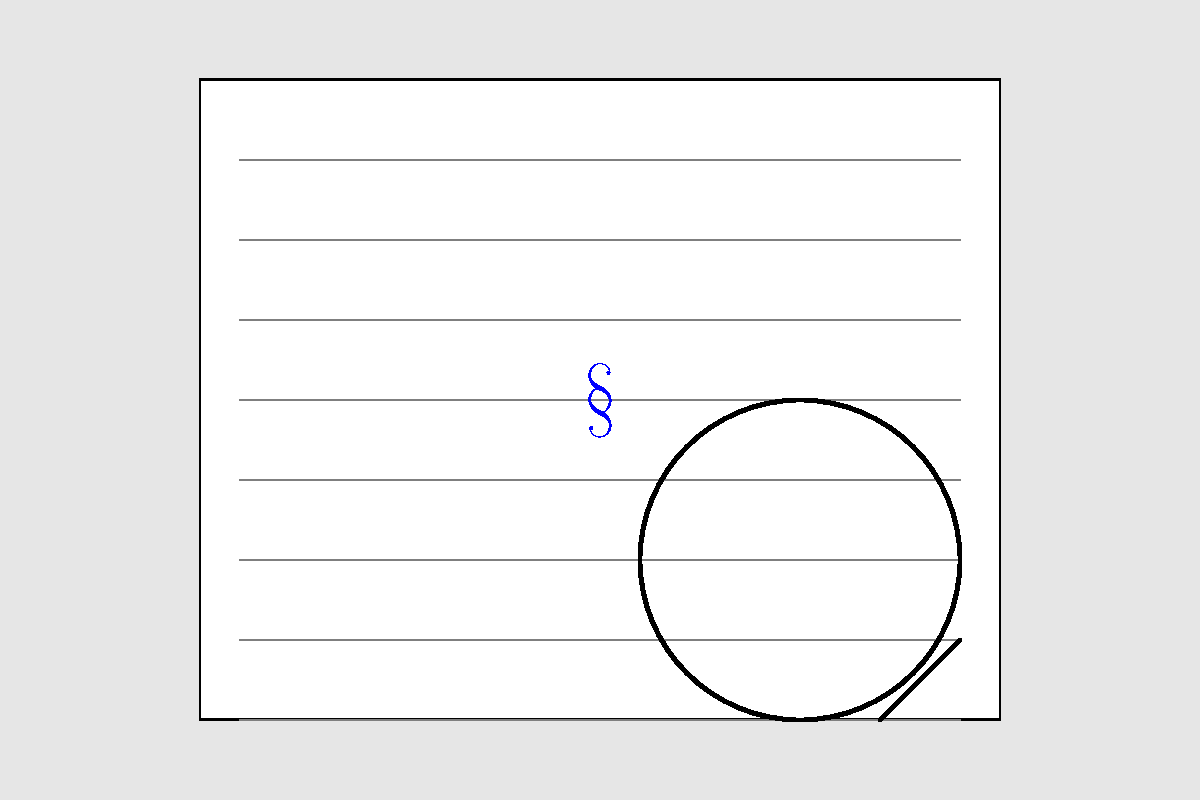In the legal document shown above, a crucial piece of evidence is hidden. What symbol represents this hidden clue, and what area of law does it typically relate to? To solve this visual puzzle, follow these steps:

1. Examine the image carefully, looking for any unusual or out-of-place elements.
2. Notice the blue symbol "§" in the center of the document.
3. Recognize that "§" is the section symbol, commonly used in legal writing.
4. The section symbol (§) is typically used to refer to specific sections of statutes, codes, or regulations.
5. In legal practice, this symbol is most commonly associated with statutory law.
6. Statutory law refers to written laws passed by legislative bodies, as opposed to case law or administrative regulations.

Therefore, the hidden clue is the section symbol (§), which typically relates to statutory law.
Answer: § (section symbol); statutory law 